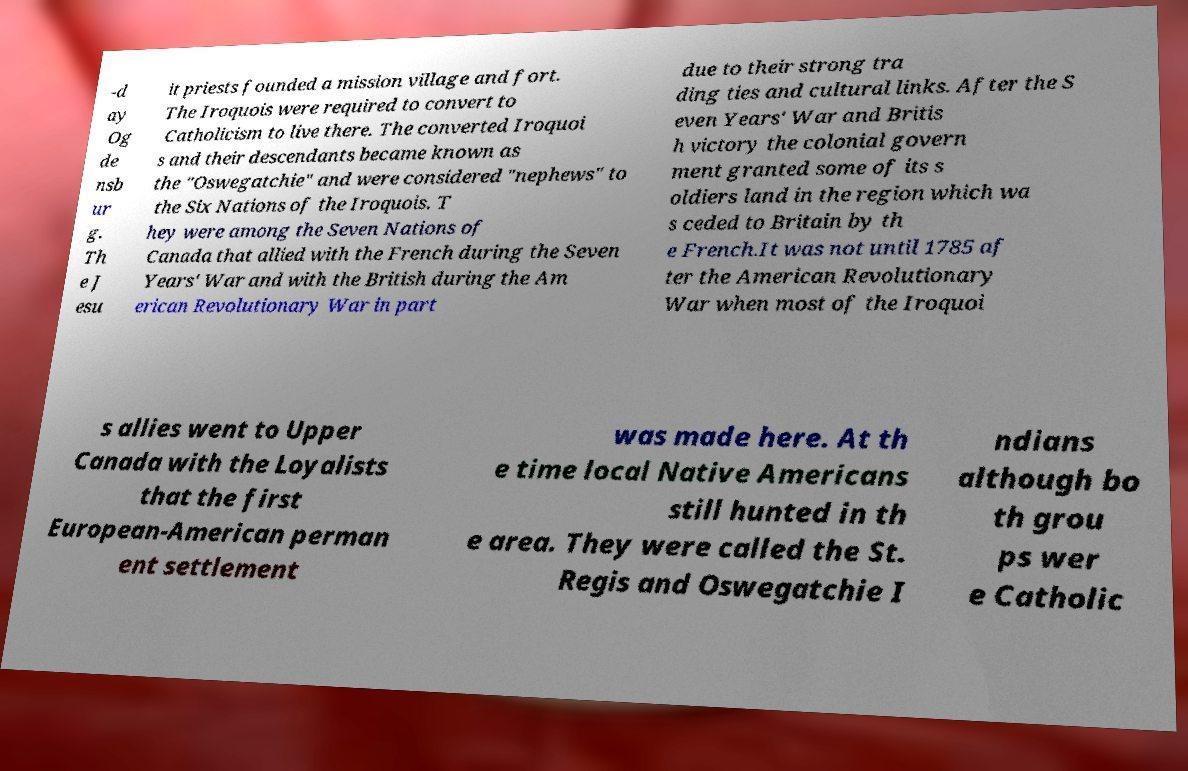Please identify and transcribe the text found in this image. -d ay Og de nsb ur g. Th e J esu it priests founded a mission village and fort. The Iroquois were required to convert to Catholicism to live there. The converted Iroquoi s and their descendants became known as the "Oswegatchie" and were considered "nephews" to the Six Nations of the Iroquois. T hey were among the Seven Nations of Canada that allied with the French during the Seven Years' War and with the British during the Am erican Revolutionary War in part due to their strong tra ding ties and cultural links. After the S even Years' War and Britis h victory the colonial govern ment granted some of its s oldiers land in the region which wa s ceded to Britain by th e French.It was not until 1785 af ter the American Revolutionary War when most of the Iroquoi s allies went to Upper Canada with the Loyalists that the first European-American perman ent settlement was made here. At th e time local Native Americans still hunted in th e area. They were called the St. Regis and Oswegatchie I ndians although bo th grou ps wer e Catholic 